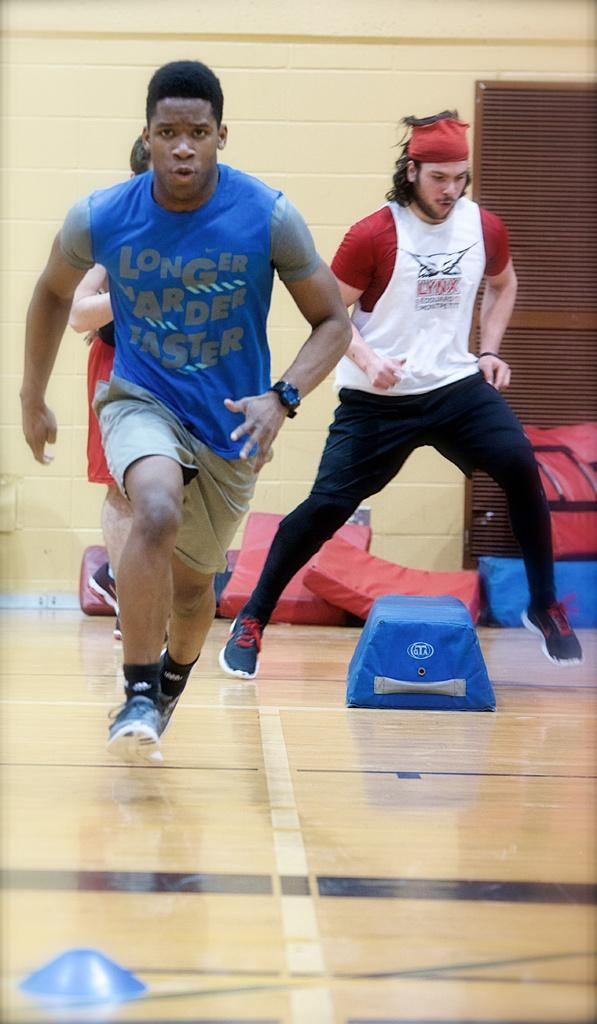How many people are present in the image? There are three people in the image. What can be observed about the people's clothing? The people are wearing different color dresses. What colors can be seen in the background of the image? There are blue and red color objects in the background. What is the color of the wall in the background? There is a cream color wall in the background. What riddle is being solved by the people in the image? There is no riddle being solved in the image; it simply shows three people wearing different color dresses with a background featuring blue and red objects and a cream color wall. 